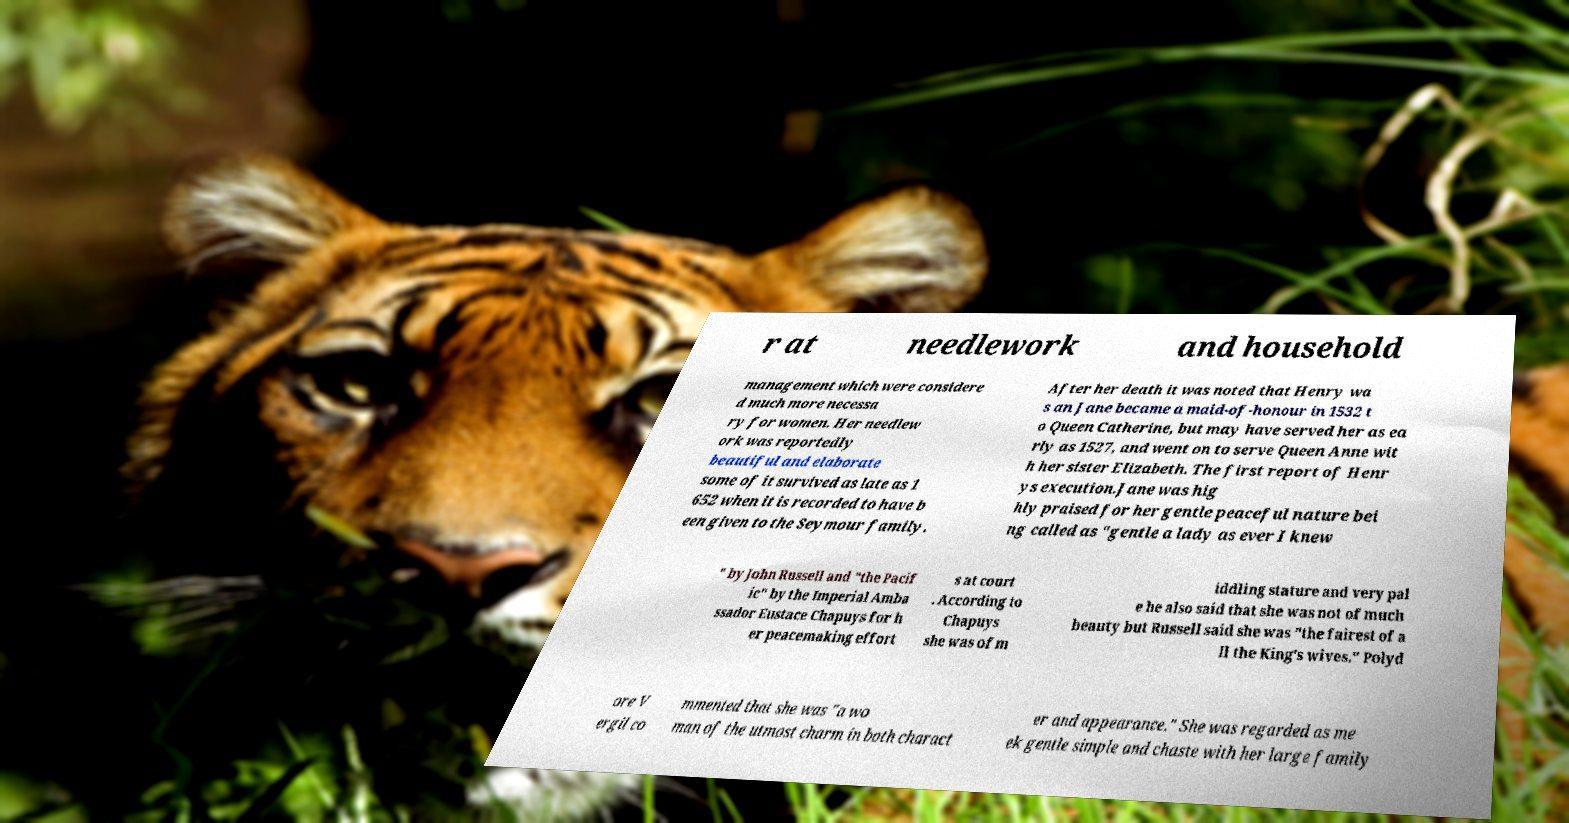Can you accurately transcribe the text from the provided image for me? r at needlework and household management which were considere d much more necessa ry for women. Her needlew ork was reportedly beautiful and elaborate some of it survived as late as 1 652 when it is recorded to have b een given to the Seymour family. After her death it was noted that Henry wa s an Jane became a maid-of-honour in 1532 t o Queen Catherine, but may have served her as ea rly as 1527, and went on to serve Queen Anne wit h her sister Elizabeth. The first report of Henr ys execution.Jane was hig hly praised for her gentle peaceful nature bei ng called as "gentle a lady as ever I knew " by John Russell and "the Pacif ic" by the Imperial Amba ssador Eustace Chapuys for h er peacemaking effort s at court . According to Chapuys she was of m iddling stature and very pal e he also said that she was not of much beauty but Russell said she was "the fairest of a ll the King's wives." Polyd ore V ergil co mmented that she was "a wo man of the utmost charm in both charact er and appearance." She was regarded as me ek gentle simple and chaste with her large family 